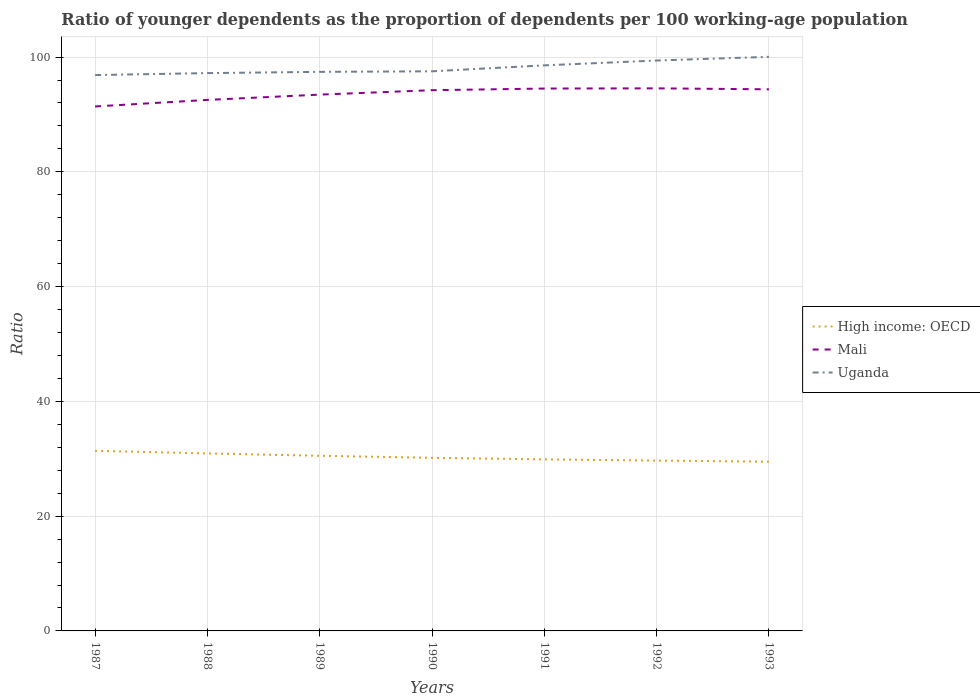Is the number of lines equal to the number of legend labels?
Your answer should be very brief. Yes. Across all years, what is the maximum age dependency ratio(young) in High income: OECD?
Offer a very short reply. 29.49. What is the total age dependency ratio(young) in Mali in the graph?
Your answer should be compact. -2.01. What is the difference between the highest and the second highest age dependency ratio(young) in Uganda?
Provide a short and direct response. 3.18. Is the age dependency ratio(young) in Mali strictly greater than the age dependency ratio(young) in Uganda over the years?
Keep it short and to the point. Yes. What is the difference between two consecutive major ticks on the Y-axis?
Keep it short and to the point. 20. Where does the legend appear in the graph?
Keep it short and to the point. Center right. How are the legend labels stacked?
Offer a very short reply. Vertical. What is the title of the graph?
Make the answer very short. Ratio of younger dependents as the proportion of dependents per 100 working-age population. What is the label or title of the Y-axis?
Your answer should be compact. Ratio. What is the Ratio of High income: OECD in 1987?
Provide a short and direct response. 31.38. What is the Ratio in Mali in 1987?
Provide a short and direct response. 91.39. What is the Ratio of Uganda in 1987?
Provide a succinct answer. 96.86. What is the Ratio in High income: OECD in 1988?
Provide a short and direct response. 30.93. What is the Ratio of Mali in 1988?
Your answer should be compact. 92.53. What is the Ratio in Uganda in 1988?
Offer a very short reply. 97.2. What is the Ratio of High income: OECD in 1989?
Make the answer very short. 30.52. What is the Ratio of Mali in 1989?
Your answer should be compact. 93.45. What is the Ratio of Uganda in 1989?
Your answer should be very brief. 97.42. What is the Ratio of High income: OECD in 1990?
Keep it short and to the point. 30.17. What is the Ratio of Mali in 1990?
Your answer should be compact. 94.23. What is the Ratio of Uganda in 1990?
Ensure brevity in your answer.  97.52. What is the Ratio of High income: OECD in 1991?
Provide a succinct answer. 29.9. What is the Ratio in Mali in 1991?
Ensure brevity in your answer.  94.51. What is the Ratio in Uganda in 1991?
Make the answer very short. 98.56. What is the Ratio in High income: OECD in 1992?
Provide a succinct answer. 29.68. What is the Ratio of Mali in 1992?
Ensure brevity in your answer.  94.55. What is the Ratio in Uganda in 1992?
Provide a succinct answer. 99.4. What is the Ratio in High income: OECD in 1993?
Ensure brevity in your answer.  29.49. What is the Ratio in Mali in 1993?
Keep it short and to the point. 94.38. What is the Ratio in Uganda in 1993?
Provide a succinct answer. 100.04. Across all years, what is the maximum Ratio of High income: OECD?
Make the answer very short. 31.38. Across all years, what is the maximum Ratio in Mali?
Your response must be concise. 94.55. Across all years, what is the maximum Ratio in Uganda?
Offer a very short reply. 100.04. Across all years, what is the minimum Ratio of High income: OECD?
Offer a terse response. 29.49. Across all years, what is the minimum Ratio in Mali?
Offer a terse response. 91.39. Across all years, what is the minimum Ratio of Uganda?
Provide a short and direct response. 96.86. What is the total Ratio of High income: OECD in the graph?
Make the answer very short. 212.07. What is the total Ratio in Mali in the graph?
Provide a short and direct response. 655.05. What is the total Ratio of Uganda in the graph?
Your answer should be very brief. 687. What is the difference between the Ratio of High income: OECD in 1987 and that in 1988?
Provide a short and direct response. 0.45. What is the difference between the Ratio of Mali in 1987 and that in 1988?
Ensure brevity in your answer.  -1.14. What is the difference between the Ratio in Uganda in 1987 and that in 1988?
Your answer should be very brief. -0.34. What is the difference between the Ratio in High income: OECD in 1987 and that in 1989?
Your answer should be compact. 0.87. What is the difference between the Ratio in Mali in 1987 and that in 1989?
Offer a very short reply. -2.06. What is the difference between the Ratio in Uganda in 1987 and that in 1989?
Your answer should be very brief. -0.56. What is the difference between the Ratio of High income: OECD in 1987 and that in 1990?
Offer a terse response. 1.22. What is the difference between the Ratio of Mali in 1987 and that in 1990?
Your response must be concise. -2.83. What is the difference between the Ratio of Uganda in 1987 and that in 1990?
Make the answer very short. -0.66. What is the difference between the Ratio of High income: OECD in 1987 and that in 1991?
Provide a short and direct response. 1.49. What is the difference between the Ratio in Mali in 1987 and that in 1991?
Keep it short and to the point. -3.12. What is the difference between the Ratio of Uganda in 1987 and that in 1991?
Your response must be concise. -1.69. What is the difference between the Ratio in High income: OECD in 1987 and that in 1992?
Your answer should be very brief. 1.7. What is the difference between the Ratio of Mali in 1987 and that in 1992?
Keep it short and to the point. -3.16. What is the difference between the Ratio of Uganda in 1987 and that in 1992?
Provide a succinct answer. -2.54. What is the difference between the Ratio in High income: OECD in 1987 and that in 1993?
Your answer should be very brief. 1.89. What is the difference between the Ratio in Mali in 1987 and that in 1993?
Offer a very short reply. -2.99. What is the difference between the Ratio in Uganda in 1987 and that in 1993?
Make the answer very short. -3.18. What is the difference between the Ratio in High income: OECD in 1988 and that in 1989?
Your answer should be compact. 0.41. What is the difference between the Ratio in Mali in 1988 and that in 1989?
Make the answer very short. -0.92. What is the difference between the Ratio of Uganda in 1988 and that in 1989?
Offer a terse response. -0.22. What is the difference between the Ratio of High income: OECD in 1988 and that in 1990?
Keep it short and to the point. 0.77. What is the difference between the Ratio in Mali in 1988 and that in 1990?
Provide a succinct answer. -1.69. What is the difference between the Ratio in Uganda in 1988 and that in 1990?
Your answer should be compact. -0.31. What is the difference between the Ratio of High income: OECD in 1988 and that in 1991?
Offer a terse response. 1.04. What is the difference between the Ratio in Mali in 1988 and that in 1991?
Provide a succinct answer. -1.98. What is the difference between the Ratio of Uganda in 1988 and that in 1991?
Offer a very short reply. -1.35. What is the difference between the Ratio of High income: OECD in 1988 and that in 1992?
Provide a succinct answer. 1.25. What is the difference between the Ratio of Mali in 1988 and that in 1992?
Your answer should be very brief. -2.01. What is the difference between the Ratio of Uganda in 1988 and that in 1992?
Provide a short and direct response. -2.19. What is the difference between the Ratio of High income: OECD in 1988 and that in 1993?
Keep it short and to the point. 1.44. What is the difference between the Ratio in Mali in 1988 and that in 1993?
Offer a terse response. -1.85. What is the difference between the Ratio in Uganda in 1988 and that in 1993?
Offer a terse response. -2.84. What is the difference between the Ratio of High income: OECD in 1989 and that in 1990?
Offer a terse response. 0.35. What is the difference between the Ratio of Mali in 1989 and that in 1990?
Offer a very short reply. -0.77. What is the difference between the Ratio of Uganda in 1989 and that in 1990?
Offer a very short reply. -0.1. What is the difference between the Ratio in High income: OECD in 1989 and that in 1991?
Provide a succinct answer. 0.62. What is the difference between the Ratio of Mali in 1989 and that in 1991?
Your answer should be very brief. -1.06. What is the difference between the Ratio of Uganda in 1989 and that in 1991?
Your response must be concise. -1.13. What is the difference between the Ratio in High income: OECD in 1989 and that in 1992?
Keep it short and to the point. 0.83. What is the difference between the Ratio in Mali in 1989 and that in 1992?
Your answer should be very brief. -1.09. What is the difference between the Ratio of Uganda in 1989 and that in 1992?
Ensure brevity in your answer.  -1.97. What is the difference between the Ratio in High income: OECD in 1989 and that in 1993?
Make the answer very short. 1.03. What is the difference between the Ratio of Mali in 1989 and that in 1993?
Ensure brevity in your answer.  -0.93. What is the difference between the Ratio of Uganda in 1989 and that in 1993?
Your response must be concise. -2.62. What is the difference between the Ratio in High income: OECD in 1990 and that in 1991?
Provide a short and direct response. 0.27. What is the difference between the Ratio in Mali in 1990 and that in 1991?
Keep it short and to the point. -0.29. What is the difference between the Ratio of Uganda in 1990 and that in 1991?
Your answer should be compact. -1.04. What is the difference between the Ratio in High income: OECD in 1990 and that in 1992?
Offer a terse response. 0.48. What is the difference between the Ratio of Mali in 1990 and that in 1992?
Ensure brevity in your answer.  -0.32. What is the difference between the Ratio in Uganda in 1990 and that in 1992?
Offer a terse response. -1.88. What is the difference between the Ratio of High income: OECD in 1990 and that in 1993?
Provide a succinct answer. 0.67. What is the difference between the Ratio in Mali in 1990 and that in 1993?
Provide a short and direct response. -0.16. What is the difference between the Ratio of Uganda in 1990 and that in 1993?
Your response must be concise. -2.52. What is the difference between the Ratio of High income: OECD in 1991 and that in 1992?
Your answer should be compact. 0.21. What is the difference between the Ratio of Mali in 1991 and that in 1992?
Provide a short and direct response. -0.03. What is the difference between the Ratio of Uganda in 1991 and that in 1992?
Offer a very short reply. -0.84. What is the difference between the Ratio of High income: OECD in 1991 and that in 1993?
Your response must be concise. 0.41. What is the difference between the Ratio of Mali in 1991 and that in 1993?
Keep it short and to the point. 0.13. What is the difference between the Ratio of Uganda in 1991 and that in 1993?
Give a very brief answer. -1.49. What is the difference between the Ratio of High income: OECD in 1992 and that in 1993?
Your response must be concise. 0.19. What is the difference between the Ratio in Mali in 1992 and that in 1993?
Your response must be concise. 0.17. What is the difference between the Ratio in Uganda in 1992 and that in 1993?
Provide a succinct answer. -0.65. What is the difference between the Ratio of High income: OECD in 1987 and the Ratio of Mali in 1988?
Offer a terse response. -61.15. What is the difference between the Ratio of High income: OECD in 1987 and the Ratio of Uganda in 1988?
Your answer should be very brief. -65.82. What is the difference between the Ratio in Mali in 1987 and the Ratio in Uganda in 1988?
Make the answer very short. -5.81. What is the difference between the Ratio of High income: OECD in 1987 and the Ratio of Mali in 1989?
Your response must be concise. -62.07. What is the difference between the Ratio of High income: OECD in 1987 and the Ratio of Uganda in 1989?
Your answer should be compact. -66.04. What is the difference between the Ratio of Mali in 1987 and the Ratio of Uganda in 1989?
Keep it short and to the point. -6.03. What is the difference between the Ratio in High income: OECD in 1987 and the Ratio in Mali in 1990?
Your answer should be compact. -62.84. What is the difference between the Ratio of High income: OECD in 1987 and the Ratio of Uganda in 1990?
Your answer should be compact. -66.13. What is the difference between the Ratio in Mali in 1987 and the Ratio in Uganda in 1990?
Offer a very short reply. -6.13. What is the difference between the Ratio of High income: OECD in 1987 and the Ratio of Mali in 1991?
Your response must be concise. -63.13. What is the difference between the Ratio of High income: OECD in 1987 and the Ratio of Uganda in 1991?
Your response must be concise. -67.17. What is the difference between the Ratio in Mali in 1987 and the Ratio in Uganda in 1991?
Your answer should be very brief. -7.16. What is the difference between the Ratio in High income: OECD in 1987 and the Ratio in Mali in 1992?
Provide a succinct answer. -63.16. What is the difference between the Ratio of High income: OECD in 1987 and the Ratio of Uganda in 1992?
Your response must be concise. -68.01. What is the difference between the Ratio in Mali in 1987 and the Ratio in Uganda in 1992?
Your response must be concise. -8. What is the difference between the Ratio in High income: OECD in 1987 and the Ratio in Mali in 1993?
Give a very brief answer. -63. What is the difference between the Ratio in High income: OECD in 1987 and the Ratio in Uganda in 1993?
Provide a succinct answer. -68.66. What is the difference between the Ratio in Mali in 1987 and the Ratio in Uganda in 1993?
Your response must be concise. -8.65. What is the difference between the Ratio of High income: OECD in 1988 and the Ratio of Mali in 1989?
Ensure brevity in your answer.  -62.52. What is the difference between the Ratio of High income: OECD in 1988 and the Ratio of Uganda in 1989?
Your answer should be compact. -66.49. What is the difference between the Ratio of Mali in 1988 and the Ratio of Uganda in 1989?
Offer a terse response. -4.89. What is the difference between the Ratio of High income: OECD in 1988 and the Ratio of Mali in 1990?
Offer a very short reply. -63.29. What is the difference between the Ratio in High income: OECD in 1988 and the Ratio in Uganda in 1990?
Provide a short and direct response. -66.59. What is the difference between the Ratio in Mali in 1988 and the Ratio in Uganda in 1990?
Give a very brief answer. -4.98. What is the difference between the Ratio in High income: OECD in 1988 and the Ratio in Mali in 1991?
Provide a succinct answer. -63.58. What is the difference between the Ratio in High income: OECD in 1988 and the Ratio in Uganda in 1991?
Keep it short and to the point. -67.62. What is the difference between the Ratio in Mali in 1988 and the Ratio in Uganda in 1991?
Make the answer very short. -6.02. What is the difference between the Ratio in High income: OECD in 1988 and the Ratio in Mali in 1992?
Your answer should be compact. -63.62. What is the difference between the Ratio in High income: OECD in 1988 and the Ratio in Uganda in 1992?
Ensure brevity in your answer.  -68.46. What is the difference between the Ratio of Mali in 1988 and the Ratio of Uganda in 1992?
Ensure brevity in your answer.  -6.86. What is the difference between the Ratio in High income: OECD in 1988 and the Ratio in Mali in 1993?
Give a very brief answer. -63.45. What is the difference between the Ratio of High income: OECD in 1988 and the Ratio of Uganda in 1993?
Your answer should be compact. -69.11. What is the difference between the Ratio in Mali in 1988 and the Ratio in Uganda in 1993?
Your answer should be very brief. -7.51. What is the difference between the Ratio in High income: OECD in 1989 and the Ratio in Mali in 1990?
Make the answer very short. -63.71. What is the difference between the Ratio of High income: OECD in 1989 and the Ratio of Uganda in 1990?
Provide a succinct answer. -67. What is the difference between the Ratio of Mali in 1989 and the Ratio of Uganda in 1990?
Provide a succinct answer. -4.06. What is the difference between the Ratio in High income: OECD in 1989 and the Ratio in Mali in 1991?
Give a very brief answer. -64. What is the difference between the Ratio in High income: OECD in 1989 and the Ratio in Uganda in 1991?
Provide a succinct answer. -68.04. What is the difference between the Ratio of Mali in 1989 and the Ratio of Uganda in 1991?
Ensure brevity in your answer.  -5.1. What is the difference between the Ratio of High income: OECD in 1989 and the Ratio of Mali in 1992?
Give a very brief answer. -64.03. What is the difference between the Ratio in High income: OECD in 1989 and the Ratio in Uganda in 1992?
Your answer should be very brief. -68.88. What is the difference between the Ratio of Mali in 1989 and the Ratio of Uganda in 1992?
Offer a terse response. -5.94. What is the difference between the Ratio of High income: OECD in 1989 and the Ratio of Mali in 1993?
Offer a terse response. -63.86. What is the difference between the Ratio in High income: OECD in 1989 and the Ratio in Uganda in 1993?
Your answer should be very brief. -69.52. What is the difference between the Ratio of Mali in 1989 and the Ratio of Uganda in 1993?
Make the answer very short. -6.59. What is the difference between the Ratio of High income: OECD in 1990 and the Ratio of Mali in 1991?
Your response must be concise. -64.35. What is the difference between the Ratio in High income: OECD in 1990 and the Ratio in Uganda in 1991?
Make the answer very short. -68.39. What is the difference between the Ratio of Mali in 1990 and the Ratio of Uganda in 1991?
Provide a short and direct response. -4.33. What is the difference between the Ratio of High income: OECD in 1990 and the Ratio of Mali in 1992?
Your answer should be very brief. -64.38. What is the difference between the Ratio in High income: OECD in 1990 and the Ratio in Uganda in 1992?
Your answer should be compact. -69.23. What is the difference between the Ratio of Mali in 1990 and the Ratio of Uganda in 1992?
Make the answer very short. -5.17. What is the difference between the Ratio of High income: OECD in 1990 and the Ratio of Mali in 1993?
Your answer should be compact. -64.22. What is the difference between the Ratio of High income: OECD in 1990 and the Ratio of Uganda in 1993?
Ensure brevity in your answer.  -69.88. What is the difference between the Ratio in Mali in 1990 and the Ratio in Uganda in 1993?
Your answer should be compact. -5.82. What is the difference between the Ratio in High income: OECD in 1991 and the Ratio in Mali in 1992?
Provide a succinct answer. -64.65. What is the difference between the Ratio in High income: OECD in 1991 and the Ratio in Uganda in 1992?
Give a very brief answer. -69.5. What is the difference between the Ratio of Mali in 1991 and the Ratio of Uganda in 1992?
Your answer should be very brief. -4.88. What is the difference between the Ratio of High income: OECD in 1991 and the Ratio of Mali in 1993?
Keep it short and to the point. -64.48. What is the difference between the Ratio of High income: OECD in 1991 and the Ratio of Uganda in 1993?
Your answer should be compact. -70.14. What is the difference between the Ratio in Mali in 1991 and the Ratio in Uganda in 1993?
Your response must be concise. -5.53. What is the difference between the Ratio of High income: OECD in 1992 and the Ratio of Mali in 1993?
Your response must be concise. -64.7. What is the difference between the Ratio of High income: OECD in 1992 and the Ratio of Uganda in 1993?
Make the answer very short. -70.36. What is the difference between the Ratio of Mali in 1992 and the Ratio of Uganda in 1993?
Give a very brief answer. -5.49. What is the average Ratio in High income: OECD per year?
Your response must be concise. 30.3. What is the average Ratio of Mali per year?
Give a very brief answer. 93.58. What is the average Ratio of Uganda per year?
Make the answer very short. 98.14. In the year 1987, what is the difference between the Ratio in High income: OECD and Ratio in Mali?
Offer a terse response. -60.01. In the year 1987, what is the difference between the Ratio of High income: OECD and Ratio of Uganda?
Your answer should be very brief. -65.48. In the year 1987, what is the difference between the Ratio in Mali and Ratio in Uganda?
Make the answer very short. -5.47. In the year 1988, what is the difference between the Ratio in High income: OECD and Ratio in Mali?
Ensure brevity in your answer.  -61.6. In the year 1988, what is the difference between the Ratio of High income: OECD and Ratio of Uganda?
Offer a terse response. -66.27. In the year 1988, what is the difference between the Ratio of Mali and Ratio of Uganda?
Provide a succinct answer. -4.67. In the year 1989, what is the difference between the Ratio in High income: OECD and Ratio in Mali?
Offer a terse response. -62.94. In the year 1989, what is the difference between the Ratio of High income: OECD and Ratio of Uganda?
Your answer should be compact. -66.9. In the year 1989, what is the difference between the Ratio in Mali and Ratio in Uganda?
Offer a terse response. -3.97. In the year 1990, what is the difference between the Ratio of High income: OECD and Ratio of Mali?
Offer a very short reply. -64.06. In the year 1990, what is the difference between the Ratio of High income: OECD and Ratio of Uganda?
Keep it short and to the point. -67.35. In the year 1990, what is the difference between the Ratio of Mali and Ratio of Uganda?
Provide a succinct answer. -3.29. In the year 1991, what is the difference between the Ratio in High income: OECD and Ratio in Mali?
Give a very brief answer. -64.62. In the year 1991, what is the difference between the Ratio of High income: OECD and Ratio of Uganda?
Offer a terse response. -68.66. In the year 1991, what is the difference between the Ratio of Mali and Ratio of Uganda?
Offer a very short reply. -4.04. In the year 1992, what is the difference between the Ratio in High income: OECD and Ratio in Mali?
Ensure brevity in your answer.  -64.86. In the year 1992, what is the difference between the Ratio in High income: OECD and Ratio in Uganda?
Offer a very short reply. -69.71. In the year 1992, what is the difference between the Ratio of Mali and Ratio of Uganda?
Give a very brief answer. -4.85. In the year 1993, what is the difference between the Ratio in High income: OECD and Ratio in Mali?
Provide a succinct answer. -64.89. In the year 1993, what is the difference between the Ratio of High income: OECD and Ratio of Uganda?
Your response must be concise. -70.55. In the year 1993, what is the difference between the Ratio of Mali and Ratio of Uganda?
Offer a very short reply. -5.66. What is the ratio of the Ratio of High income: OECD in 1987 to that in 1988?
Keep it short and to the point. 1.01. What is the ratio of the Ratio of Mali in 1987 to that in 1988?
Make the answer very short. 0.99. What is the ratio of the Ratio of Uganda in 1987 to that in 1988?
Keep it short and to the point. 1. What is the ratio of the Ratio of High income: OECD in 1987 to that in 1989?
Keep it short and to the point. 1.03. What is the ratio of the Ratio of Mali in 1987 to that in 1989?
Ensure brevity in your answer.  0.98. What is the ratio of the Ratio in High income: OECD in 1987 to that in 1990?
Your response must be concise. 1.04. What is the ratio of the Ratio in Mali in 1987 to that in 1990?
Keep it short and to the point. 0.97. What is the ratio of the Ratio in High income: OECD in 1987 to that in 1991?
Provide a short and direct response. 1.05. What is the ratio of the Ratio of Mali in 1987 to that in 1991?
Offer a terse response. 0.97. What is the ratio of the Ratio of Uganda in 1987 to that in 1991?
Give a very brief answer. 0.98. What is the ratio of the Ratio of High income: OECD in 1987 to that in 1992?
Give a very brief answer. 1.06. What is the ratio of the Ratio in Mali in 1987 to that in 1992?
Keep it short and to the point. 0.97. What is the ratio of the Ratio in Uganda in 1987 to that in 1992?
Provide a succinct answer. 0.97. What is the ratio of the Ratio in High income: OECD in 1987 to that in 1993?
Provide a succinct answer. 1.06. What is the ratio of the Ratio of Mali in 1987 to that in 1993?
Keep it short and to the point. 0.97. What is the ratio of the Ratio in Uganda in 1987 to that in 1993?
Keep it short and to the point. 0.97. What is the ratio of the Ratio of High income: OECD in 1988 to that in 1989?
Make the answer very short. 1.01. What is the ratio of the Ratio in Mali in 1988 to that in 1989?
Offer a very short reply. 0.99. What is the ratio of the Ratio in High income: OECD in 1988 to that in 1990?
Your answer should be very brief. 1.03. What is the ratio of the Ratio in Mali in 1988 to that in 1990?
Ensure brevity in your answer.  0.98. What is the ratio of the Ratio in High income: OECD in 1988 to that in 1991?
Provide a short and direct response. 1.03. What is the ratio of the Ratio of Mali in 1988 to that in 1991?
Make the answer very short. 0.98. What is the ratio of the Ratio of Uganda in 1988 to that in 1991?
Make the answer very short. 0.99. What is the ratio of the Ratio of High income: OECD in 1988 to that in 1992?
Your response must be concise. 1.04. What is the ratio of the Ratio in Mali in 1988 to that in 1992?
Keep it short and to the point. 0.98. What is the ratio of the Ratio in Uganda in 1988 to that in 1992?
Provide a succinct answer. 0.98. What is the ratio of the Ratio of High income: OECD in 1988 to that in 1993?
Offer a terse response. 1.05. What is the ratio of the Ratio in Mali in 1988 to that in 1993?
Ensure brevity in your answer.  0.98. What is the ratio of the Ratio in Uganda in 1988 to that in 1993?
Offer a very short reply. 0.97. What is the ratio of the Ratio in High income: OECD in 1989 to that in 1990?
Give a very brief answer. 1.01. What is the ratio of the Ratio of High income: OECD in 1989 to that in 1991?
Your answer should be compact. 1.02. What is the ratio of the Ratio in Mali in 1989 to that in 1991?
Keep it short and to the point. 0.99. What is the ratio of the Ratio of High income: OECD in 1989 to that in 1992?
Give a very brief answer. 1.03. What is the ratio of the Ratio of Mali in 1989 to that in 1992?
Your response must be concise. 0.99. What is the ratio of the Ratio of Uganda in 1989 to that in 1992?
Keep it short and to the point. 0.98. What is the ratio of the Ratio in High income: OECD in 1989 to that in 1993?
Provide a succinct answer. 1.03. What is the ratio of the Ratio of Mali in 1989 to that in 1993?
Offer a very short reply. 0.99. What is the ratio of the Ratio of Uganda in 1989 to that in 1993?
Provide a succinct answer. 0.97. What is the ratio of the Ratio in High income: OECD in 1990 to that in 1991?
Your response must be concise. 1.01. What is the ratio of the Ratio of High income: OECD in 1990 to that in 1992?
Your answer should be compact. 1.02. What is the ratio of the Ratio of Uganda in 1990 to that in 1992?
Your response must be concise. 0.98. What is the ratio of the Ratio of High income: OECD in 1990 to that in 1993?
Your answer should be very brief. 1.02. What is the ratio of the Ratio in Uganda in 1990 to that in 1993?
Provide a short and direct response. 0.97. What is the ratio of the Ratio of High income: OECD in 1991 to that in 1993?
Your response must be concise. 1.01. What is the ratio of the Ratio in Uganda in 1991 to that in 1993?
Offer a very short reply. 0.99. What is the ratio of the Ratio of Mali in 1992 to that in 1993?
Offer a terse response. 1. What is the difference between the highest and the second highest Ratio of High income: OECD?
Make the answer very short. 0.45. What is the difference between the highest and the second highest Ratio of Mali?
Your answer should be very brief. 0.03. What is the difference between the highest and the second highest Ratio of Uganda?
Your response must be concise. 0.65. What is the difference between the highest and the lowest Ratio in High income: OECD?
Offer a very short reply. 1.89. What is the difference between the highest and the lowest Ratio of Mali?
Ensure brevity in your answer.  3.16. What is the difference between the highest and the lowest Ratio in Uganda?
Ensure brevity in your answer.  3.18. 